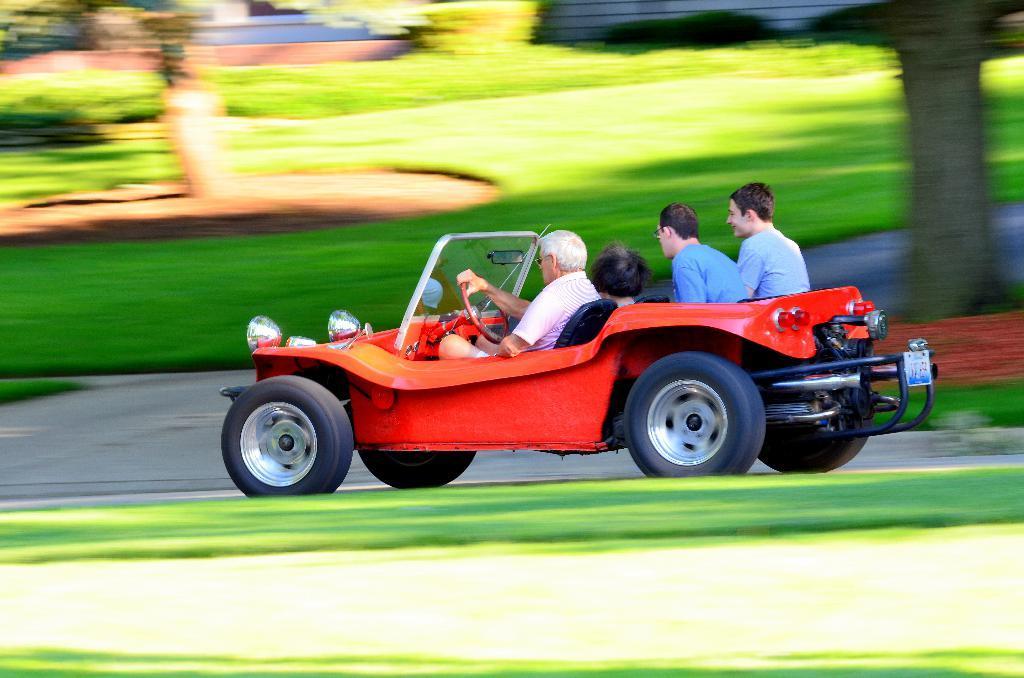Can you describe this image briefly? In this image we can see a red color car in which four people are sitting. We can see a blurred trees in the background 